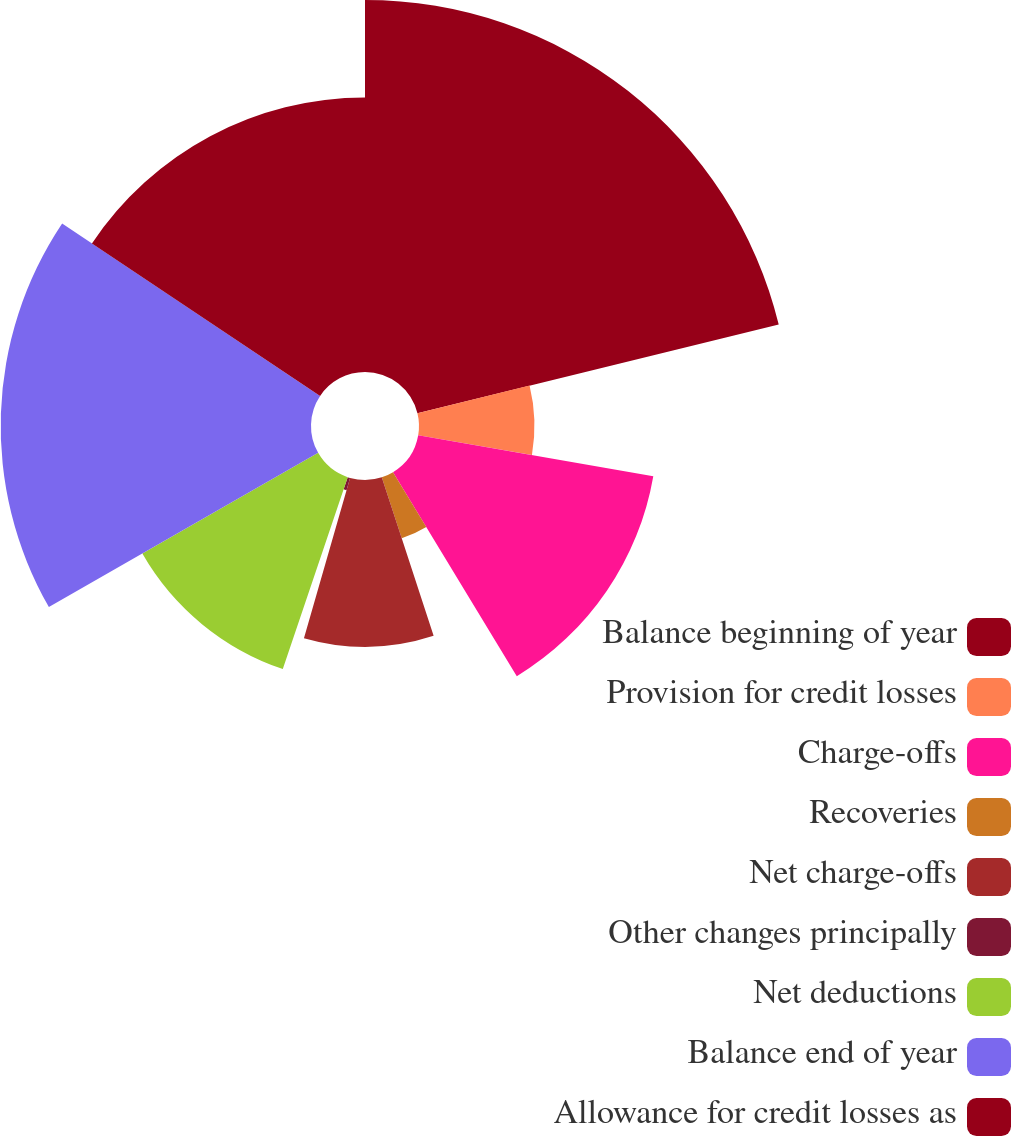Convert chart to OTSL. <chart><loc_0><loc_0><loc_500><loc_500><pie_chart><fcel>Balance beginning of year<fcel>Provision for credit losses<fcel>Charge-offs<fcel>Recoveries<fcel>Net charge-offs<fcel>Other changes principally<fcel>Net deductions<fcel>Balance end of year<fcel>Allowance for credit losses as<nl><fcel>21.17%<fcel>6.57%<fcel>13.58%<fcel>3.65%<fcel>9.49%<fcel>0.73%<fcel>11.53%<fcel>17.66%<fcel>15.62%<nl></chart> 